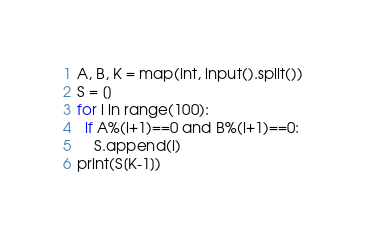<code> <loc_0><loc_0><loc_500><loc_500><_Python_>A, B, K = map(int, input().split())
S = []
for i in range(100):
  if A%(i+1)==0 and B%(i+1)==0:
    S.append(i)
print(S[K-1])</code> 